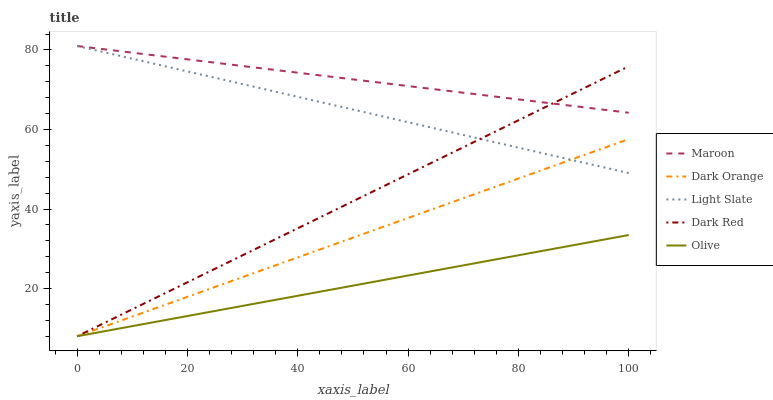Does Dark Orange have the minimum area under the curve?
Answer yes or no. No. Does Dark Orange have the maximum area under the curve?
Answer yes or no. No. Is Olive the smoothest?
Answer yes or no. No. Is Olive the roughest?
Answer yes or no. No. Does Maroon have the lowest value?
Answer yes or no. No. Does Dark Orange have the highest value?
Answer yes or no. No. Is Dark Orange less than Maroon?
Answer yes or no. Yes. Is Light Slate greater than Olive?
Answer yes or no. Yes. Does Dark Orange intersect Maroon?
Answer yes or no. No. 